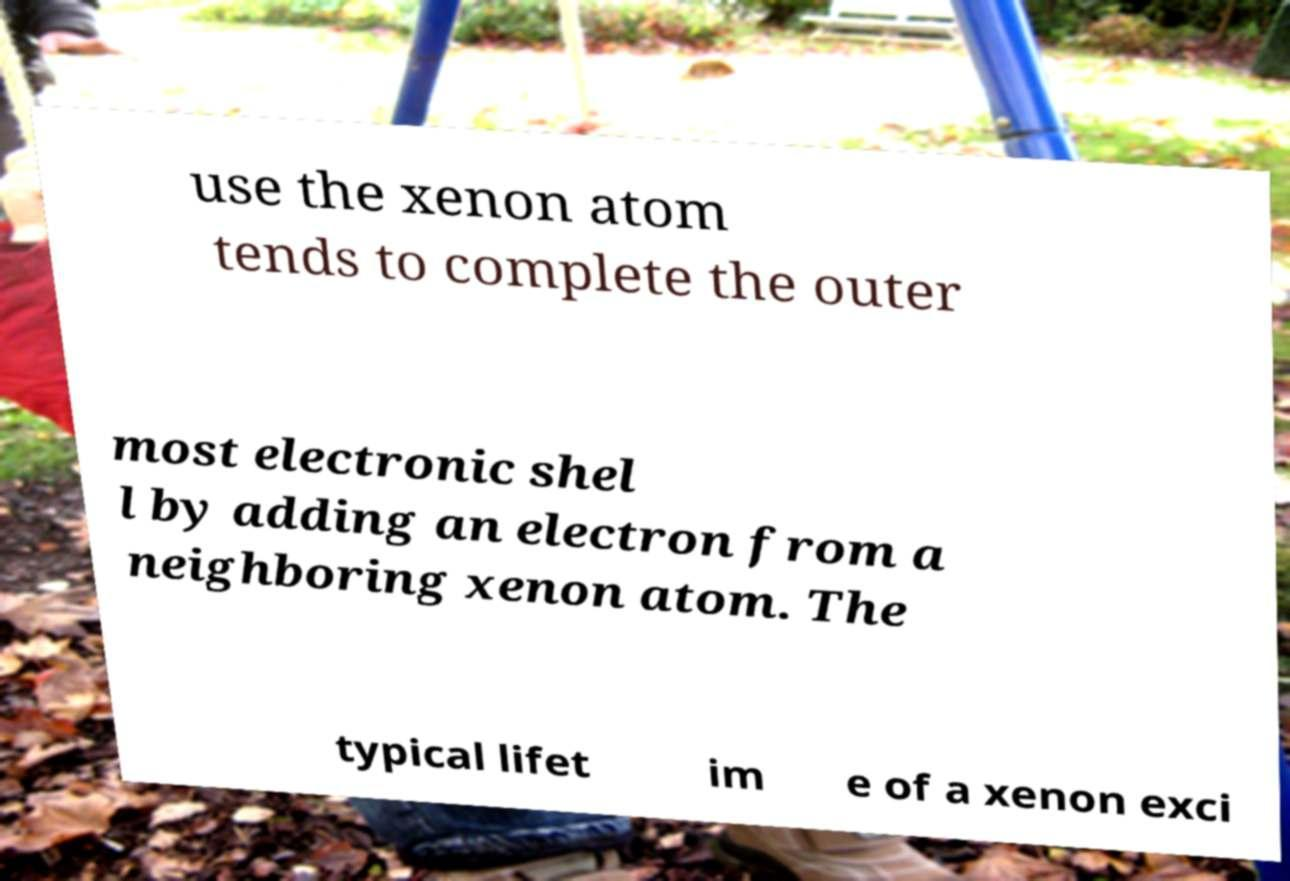Please identify and transcribe the text found in this image. use the xenon atom tends to complete the outer most electronic shel l by adding an electron from a neighboring xenon atom. The typical lifet im e of a xenon exci 